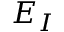Convert formula to latex. <formula><loc_0><loc_0><loc_500><loc_500>E _ { I }</formula> 